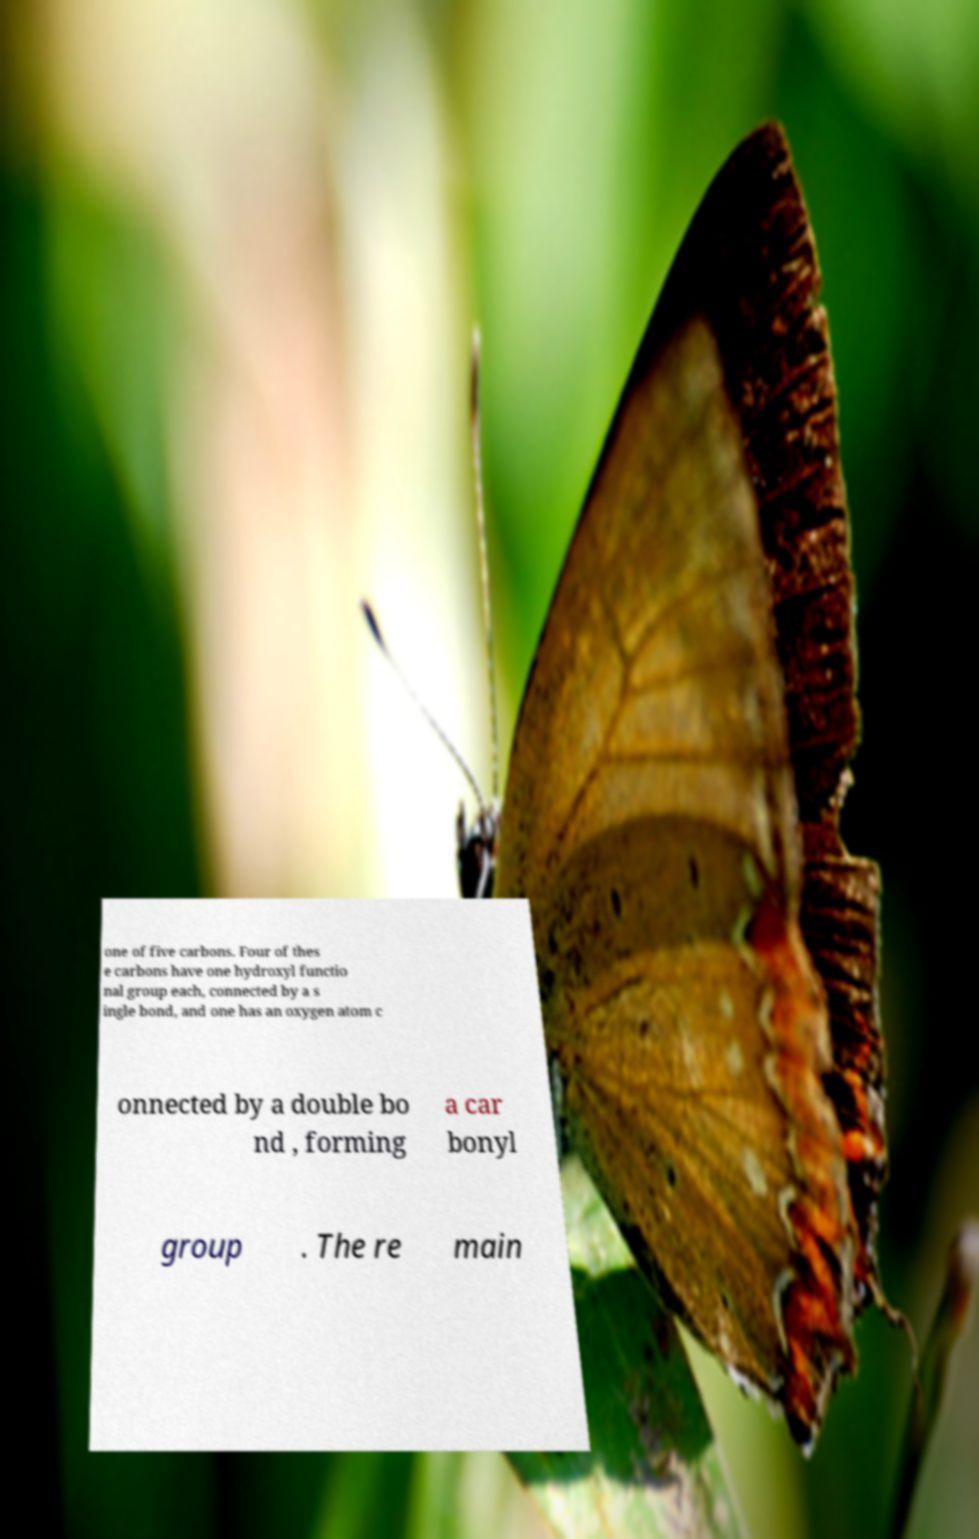Could you extract and type out the text from this image? one of five carbons. Four of thes e carbons have one hydroxyl functio nal group each, connected by a s ingle bond, and one has an oxygen atom c onnected by a double bo nd , forming a car bonyl group . The re main 